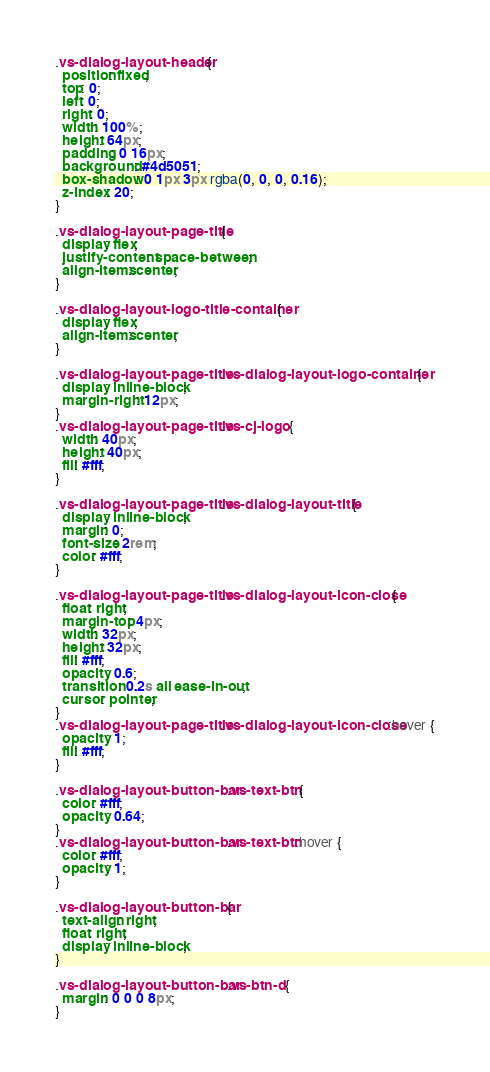Convert code to text. <code><loc_0><loc_0><loc_500><loc_500><_CSS_>.vs-dialog-layout-header {
  position: fixed;
  top: 0;
  left: 0;
  right: 0;
  width: 100%;
  height: 64px;
  padding: 0 16px;
  background: #4d5051;
  box-shadow: 0 1px 3px rgba(0, 0, 0, 0.16);
  z-index: 20;
}

.vs-dialog-layout-page-title {
  display: flex;
  justify-content: space-between;
  align-items: center;
}

.vs-dialog-layout-logo-title-container {
  display: flex;
  align-items: center;
}

.vs-dialog-layout-page-title .vs-dialog-layout-logo-container {
  display: inline-block;
  margin-right: 12px;
}
.vs-dialog-layout-page-title .vs-cj-logo {
  width: 40px;
  height: 40px;
  fill: #fff;
}

.vs-dialog-layout-page-title .vs-dialog-layout-title {
  display: inline-block;
  margin: 0;
  font-size: 2rem;
  color: #fff;
}

.vs-dialog-layout-page-title .vs-dialog-layout-icon-close {
  float: right;
  margin-top: 4px;
  width: 32px;
  height: 32px;
  fill: #fff;
  opacity: 0.6;
  transition: 0.2s all ease-in-out;
  cursor: pointer;
}
.vs-dialog-layout-page-title .vs-dialog-layout-icon-close:hover {
  opacity: 1;
  fill: #fff;
}

.vs-dialog-layout-button-bar .vs-text-btn {
  color: #fff;
  opacity: 0.64;
}
.vs-dialog-layout-button-bar .vs-text-btn:hover {
  color: #fff;
  opacity: 1;
}

.vs-dialog-layout-button-bar {
  text-align: right;
  float: right;
  display: inline-block;
}

.vs-dialog-layout-button-bar .vs-btn-d {
  margin: 0 0 0 8px;
}
</code> 